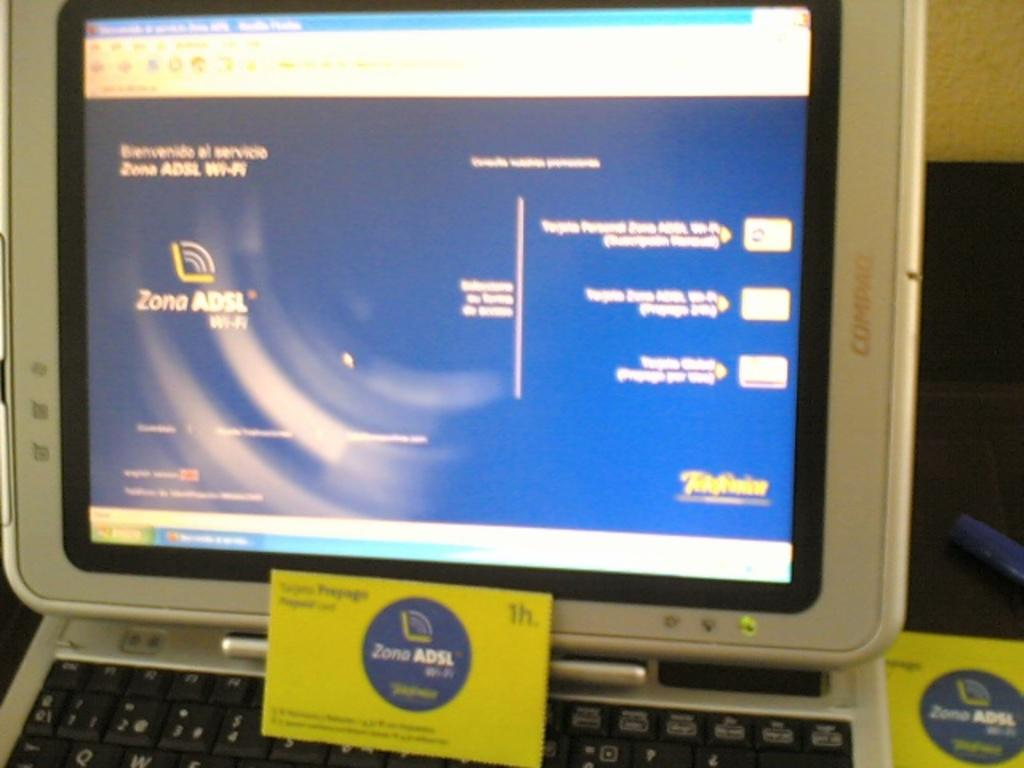<image>
Offer a succinct explanation of the picture presented. A Compaq screen displays information about Zona ADSL wi-fi. 